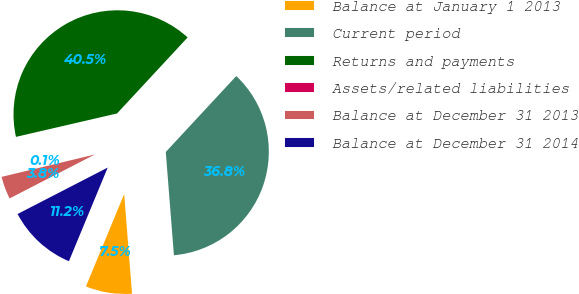<chart> <loc_0><loc_0><loc_500><loc_500><pie_chart><fcel>Balance at January 1 2013<fcel>Current period<fcel>Returns and payments<fcel>Assets/related liabilities<fcel>Balance at December 31 2013<fcel>Balance at December 31 2014<nl><fcel>7.5%<fcel>36.84%<fcel>40.53%<fcel>0.13%<fcel>3.82%<fcel>11.18%<nl></chart> 